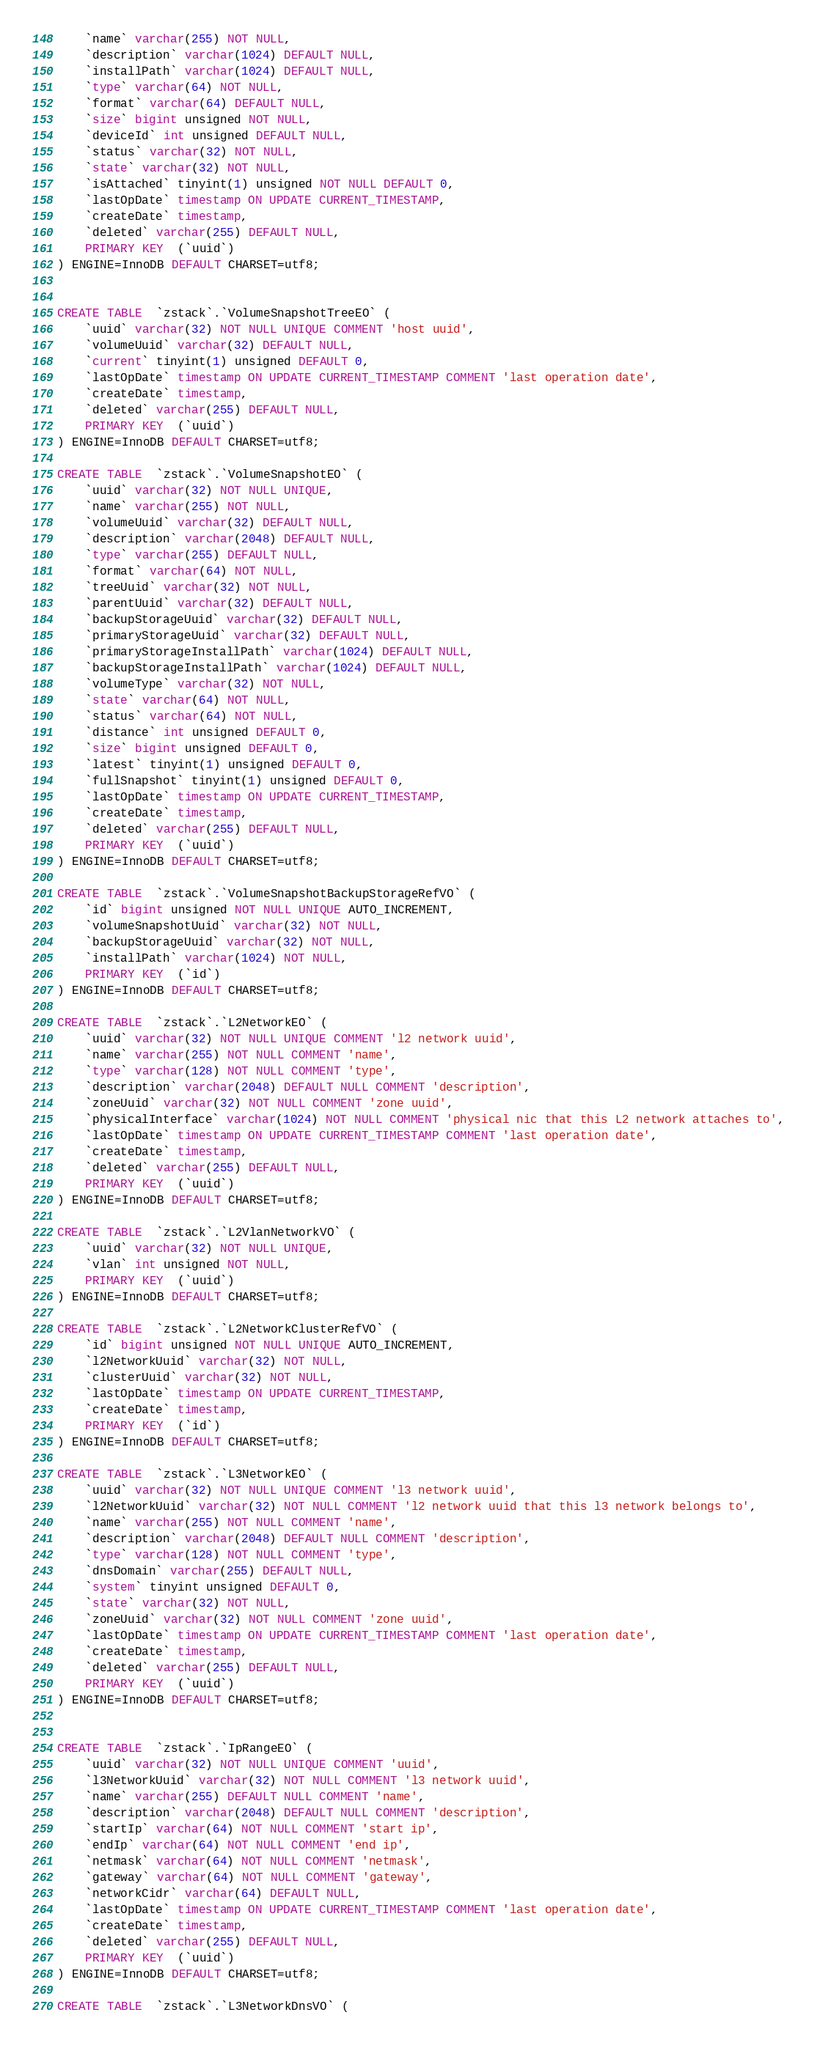<code> <loc_0><loc_0><loc_500><loc_500><_SQL_>    `name` varchar(255) NOT NULL,
    `description` varchar(1024) DEFAULT NULL,
    `installPath` varchar(1024) DEFAULT NULL,
    `type` varchar(64) NOT NULL,
    `format` varchar(64) DEFAULT NULL,
    `size` bigint unsigned NOT NULL,
    `deviceId` int unsigned DEFAULT NULL,
    `status` varchar(32) NOT NULL,
    `state` varchar(32) NOT NULL,
    `isAttached` tinyint(1) unsigned NOT NULL DEFAULT 0,
    `lastOpDate` timestamp ON UPDATE CURRENT_TIMESTAMP,
    `createDate` timestamp,
    `deleted` varchar(255) DEFAULT NULL,
    PRIMARY KEY  (`uuid`)
) ENGINE=InnoDB DEFAULT CHARSET=utf8;


CREATE TABLE  `zstack`.`VolumeSnapshotTreeEO` (
    `uuid` varchar(32) NOT NULL UNIQUE COMMENT 'host uuid',
    `volumeUuid` varchar(32) DEFAULT NULL,
    `current` tinyint(1) unsigned DEFAULT 0,
    `lastOpDate` timestamp ON UPDATE CURRENT_TIMESTAMP COMMENT 'last operation date',
    `createDate` timestamp,
    `deleted` varchar(255) DEFAULT NULL,
    PRIMARY KEY  (`uuid`)
) ENGINE=InnoDB DEFAULT CHARSET=utf8;

CREATE TABLE  `zstack`.`VolumeSnapshotEO` (
    `uuid` varchar(32) NOT NULL UNIQUE,
    `name` varchar(255) NOT NULL,
    `volumeUuid` varchar(32) DEFAULT NULL,
    `description` varchar(2048) DEFAULT NULL,
    `type` varchar(255) DEFAULT NULL,
    `format` varchar(64) NOT NULL,
    `treeUuid` varchar(32) NOT NULL,
    `parentUuid` varchar(32) DEFAULT NULL,
    `backupStorageUuid` varchar(32) DEFAULT NULL,
    `primaryStorageUuid` varchar(32) DEFAULT NULL,
    `primaryStorageInstallPath` varchar(1024) DEFAULT NULL,
    `backupStorageInstallPath` varchar(1024) DEFAULT NULL,
    `volumeType` varchar(32) NOT NULL,
    `state` varchar(64) NOT NULL,
    `status` varchar(64) NOT NULL,
    `distance` int unsigned DEFAULT 0,
    `size` bigint unsigned DEFAULT 0,
    `latest` tinyint(1) unsigned DEFAULT 0,
    `fullSnapshot` tinyint(1) unsigned DEFAULT 0,
    `lastOpDate` timestamp ON UPDATE CURRENT_TIMESTAMP,
    `createDate` timestamp,
    `deleted` varchar(255) DEFAULT NULL,
    PRIMARY KEY  (`uuid`)
) ENGINE=InnoDB DEFAULT CHARSET=utf8;

CREATE TABLE  `zstack`.`VolumeSnapshotBackupStorageRefVO` (
    `id` bigint unsigned NOT NULL UNIQUE AUTO_INCREMENT,
    `volumeSnapshotUuid` varchar(32) NOT NULL,
    `backupStorageUuid` varchar(32) NOT NULL,
    `installPath` varchar(1024) NOT NULL,
    PRIMARY KEY  (`id`)
) ENGINE=InnoDB DEFAULT CHARSET=utf8;

CREATE TABLE  `zstack`.`L2NetworkEO` (
    `uuid` varchar(32) NOT NULL UNIQUE COMMENT 'l2 network uuid',
    `name` varchar(255) NOT NULL COMMENT 'name',
    `type` varchar(128) NOT NULL COMMENT 'type',
    `description` varchar(2048) DEFAULT NULL COMMENT 'description',
    `zoneUuid` varchar(32) NOT NULL COMMENT 'zone uuid',
    `physicalInterface` varchar(1024) NOT NULL COMMENT 'physical nic that this L2 network attaches to',
    `lastOpDate` timestamp ON UPDATE CURRENT_TIMESTAMP COMMENT 'last operation date',
    `createDate` timestamp,
    `deleted` varchar(255) DEFAULT NULL,
    PRIMARY KEY  (`uuid`)
) ENGINE=InnoDB DEFAULT CHARSET=utf8;

CREATE TABLE  `zstack`.`L2VlanNetworkVO` (
    `uuid` varchar(32) NOT NULL UNIQUE,
    `vlan` int unsigned NOT NULL,
    PRIMARY KEY  (`uuid`)
) ENGINE=InnoDB DEFAULT CHARSET=utf8;

CREATE TABLE  `zstack`.`L2NetworkClusterRefVO` (
    `id` bigint unsigned NOT NULL UNIQUE AUTO_INCREMENT,
    `l2NetworkUuid` varchar(32) NOT NULL,
    `clusterUuid` varchar(32) NOT NULL,
    `lastOpDate` timestamp ON UPDATE CURRENT_TIMESTAMP,
    `createDate` timestamp,
    PRIMARY KEY  (`id`)
) ENGINE=InnoDB DEFAULT CHARSET=utf8;

CREATE TABLE  `zstack`.`L3NetworkEO` (
    `uuid` varchar(32) NOT NULL UNIQUE COMMENT 'l3 network uuid',
    `l2NetworkUuid` varchar(32) NOT NULL COMMENT 'l2 network uuid that this l3 network belongs to', 
    `name` varchar(255) NOT NULL COMMENT 'name',
    `description` varchar(2048) DEFAULT NULL COMMENT 'description',
    `type` varchar(128) NOT NULL COMMENT 'type',
    `dnsDomain` varchar(255) DEFAULT NULL,
    `system` tinyint unsigned DEFAULT 0,
    `state` varchar(32) NOT NULL,
    `zoneUuid` varchar(32) NOT NULL COMMENT 'zone uuid',
    `lastOpDate` timestamp ON UPDATE CURRENT_TIMESTAMP COMMENT 'last operation date',
    `createDate` timestamp,
    `deleted` varchar(255) DEFAULT NULL,
    PRIMARY KEY  (`uuid`)
) ENGINE=InnoDB DEFAULT CHARSET=utf8;


CREATE TABLE  `zstack`.`IpRangeEO` (
    `uuid` varchar(32) NOT NULL UNIQUE COMMENT 'uuid',
    `l3NetworkUuid` varchar(32) NOT NULL COMMENT 'l3 network uuid',
    `name` varchar(255) DEFAULT NULL COMMENT 'name',
    `description` varchar(2048) DEFAULT NULL COMMENT 'description',
    `startIp` varchar(64) NOT NULL COMMENT 'start ip',
    `endIp` varchar(64) NOT NULL COMMENT 'end ip',
    `netmask` varchar(64) NOT NULL COMMENT 'netmask',
    `gateway` varchar(64) NOT NULL COMMENT 'gateway',
    `networkCidr` varchar(64) DEFAULT NULL,
    `lastOpDate` timestamp ON UPDATE CURRENT_TIMESTAMP COMMENT 'last operation date',
    `createDate` timestamp,
    `deleted` varchar(255) DEFAULT NULL,
    PRIMARY KEY  (`uuid`)
) ENGINE=InnoDB DEFAULT CHARSET=utf8;

CREATE TABLE  `zstack`.`L3NetworkDnsVO` (</code> 